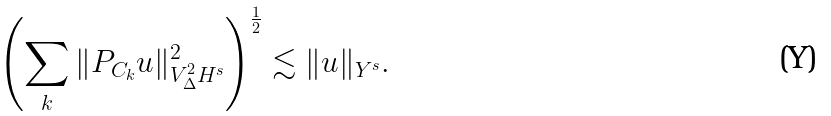Convert formula to latex. <formula><loc_0><loc_0><loc_500><loc_500>\left ( \sum _ { k } \| P _ { C _ { k } } u \| _ { V ^ { 2 } _ { \Delta } H ^ { s } } ^ { 2 } \right ) ^ { \frac { 1 } { 2 } } \lesssim \| u \| _ { Y ^ { s } } .</formula> 